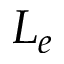Convert formula to latex. <formula><loc_0><loc_0><loc_500><loc_500>L _ { e }</formula> 